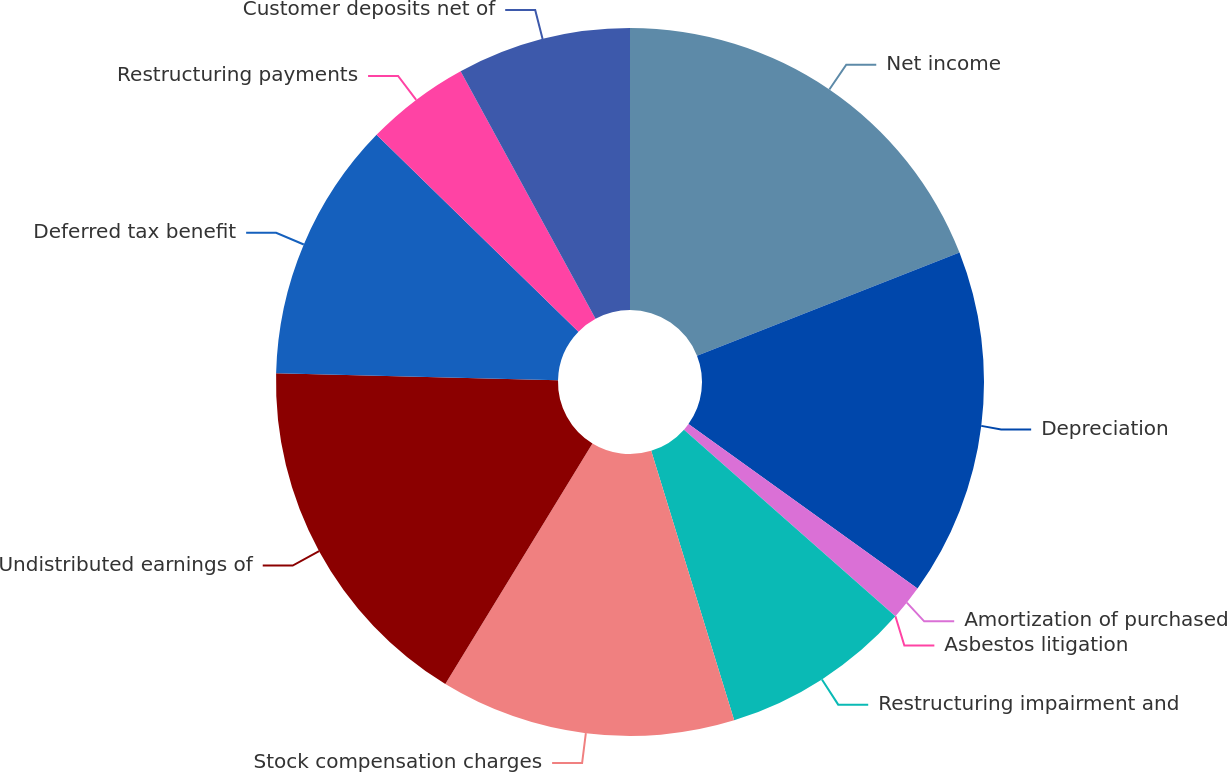Convert chart. <chart><loc_0><loc_0><loc_500><loc_500><pie_chart><fcel>Net income<fcel>Depreciation<fcel>Amortization of purchased<fcel>Asbestos litigation<fcel>Restructuring impairment and<fcel>Stock compensation charges<fcel>Undistributed earnings of<fcel>Deferred tax benefit<fcel>Restructuring payments<fcel>Customer deposits net of<nl><fcel>19.04%<fcel>15.87%<fcel>1.59%<fcel>0.01%<fcel>8.73%<fcel>13.49%<fcel>16.66%<fcel>11.9%<fcel>4.76%<fcel>7.94%<nl></chart> 